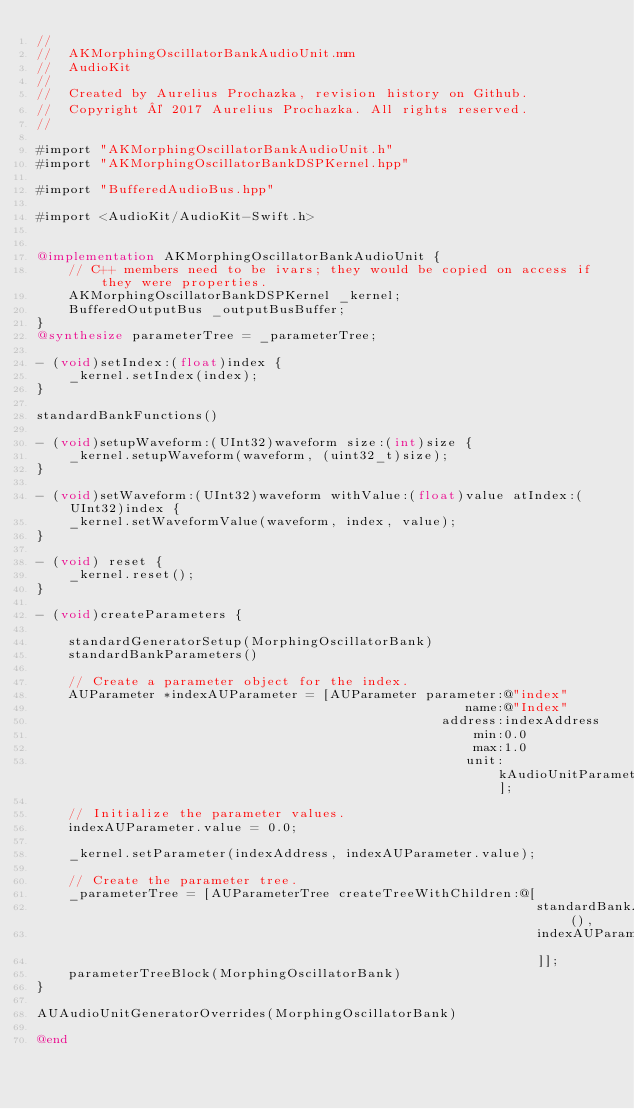<code> <loc_0><loc_0><loc_500><loc_500><_ObjectiveC_>//
//  AKMorphingOscillatorBankAudioUnit.mm
//  AudioKit
//
//  Created by Aurelius Prochazka, revision history on Github.
//  Copyright © 2017 Aurelius Prochazka. All rights reserved.
//

#import "AKMorphingOscillatorBankAudioUnit.h"
#import "AKMorphingOscillatorBankDSPKernel.hpp"

#import "BufferedAudioBus.hpp"

#import <AudioKit/AudioKit-Swift.h>


@implementation AKMorphingOscillatorBankAudioUnit {
    // C++ members need to be ivars; they would be copied on access if they were properties.
    AKMorphingOscillatorBankDSPKernel _kernel;
    BufferedOutputBus _outputBusBuffer;
}
@synthesize parameterTree = _parameterTree;

- (void)setIndex:(float)index {
    _kernel.setIndex(index);
}

standardBankFunctions()

- (void)setupWaveform:(UInt32)waveform size:(int)size {
    _kernel.setupWaveform(waveform, (uint32_t)size);
}

- (void)setWaveform:(UInt32)waveform withValue:(float)value atIndex:(UInt32)index {
    _kernel.setWaveformValue(waveform, index, value);
}

- (void) reset {
    _kernel.reset();
}

- (void)createParameters {

    standardGeneratorSetup(MorphingOscillatorBank)
    standardBankParameters()

    // Create a parameter object for the index.
    AUParameter *indexAUParameter = [AUParameter parameter:@"index"
                                                      name:@"Index"
                                                   address:indexAddress
                                                       min:0.0
                                                       max:1.0
                                                      unit:kAudioUnitParameterUnit_Generic];

    // Initialize the parameter values.
    indexAUParameter.value = 0.0;

    _kernel.setParameter(indexAddress, indexAUParameter.value);

    // Create the parameter tree.
    _parameterTree = [AUParameterTree createTreeWithChildren:@[
                                                               standardBankAUParameterList(),
                                                               indexAUParameter
                                                               ]];
    parameterTreeBlock(MorphingOscillatorBank)
}

AUAudioUnitGeneratorOverrides(MorphingOscillatorBank)

@end


</code> 